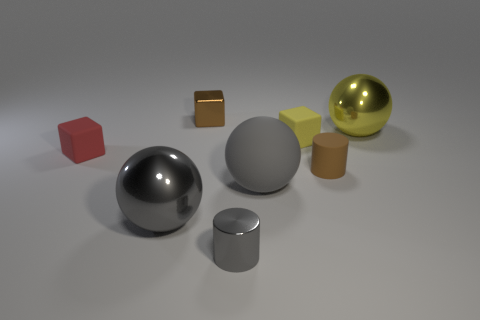Subtract all rubber cubes. How many cubes are left? 1 Add 1 yellow matte objects. How many objects exist? 9 Subtract all yellow cylinders. How many gray spheres are left? 2 Subtract all yellow balls. How many balls are left? 2 Subtract 2 cubes. How many cubes are left? 1 Add 4 tiny cyan matte balls. How many tiny cyan matte balls exist? 4 Subtract 1 brown cylinders. How many objects are left? 7 Subtract all cylinders. How many objects are left? 6 Subtract all blue cubes. Subtract all blue balls. How many cubes are left? 3 Subtract all gray metallic cubes. Subtract all red matte objects. How many objects are left? 7 